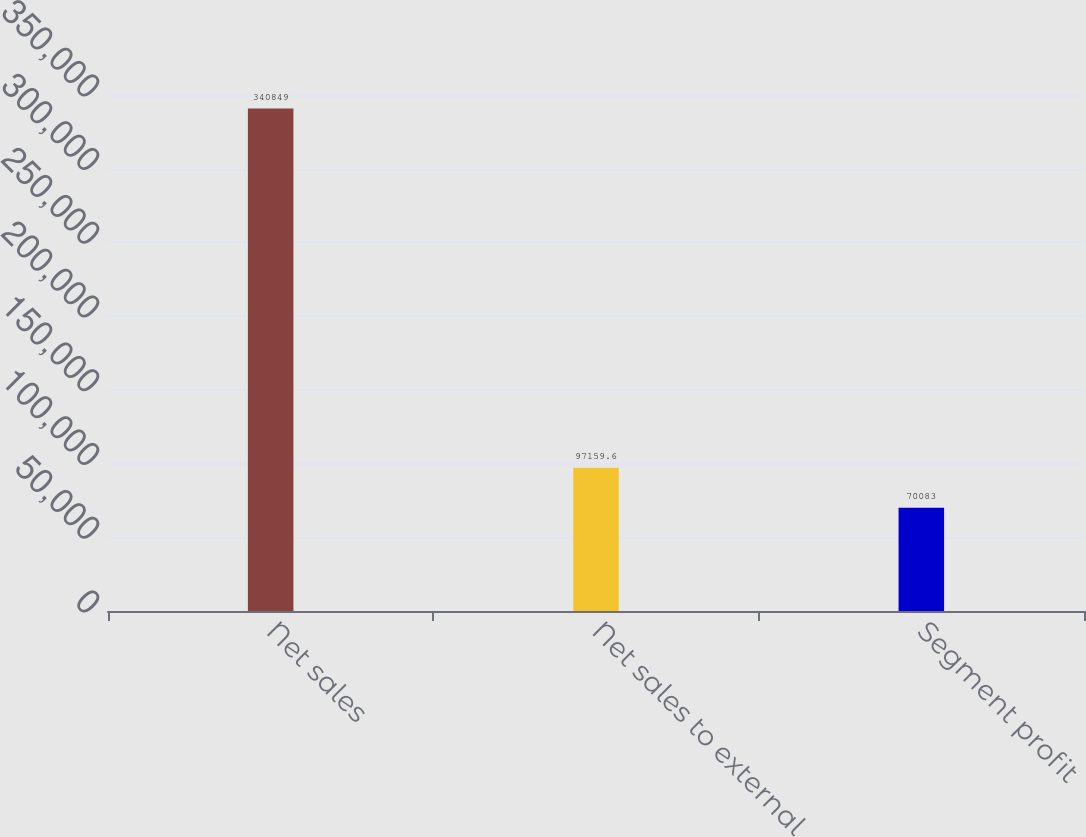Convert chart to OTSL. <chart><loc_0><loc_0><loc_500><loc_500><bar_chart><fcel>Net sales<fcel>Net sales to external<fcel>Segment profit<nl><fcel>340849<fcel>97159.6<fcel>70083<nl></chart> 